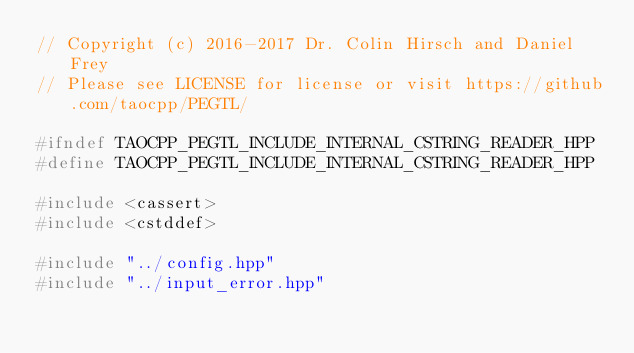<code> <loc_0><loc_0><loc_500><loc_500><_C++_>// Copyright (c) 2016-2017 Dr. Colin Hirsch and Daniel Frey
// Please see LICENSE for license or visit https://github.com/taocpp/PEGTL/

#ifndef TAOCPP_PEGTL_INCLUDE_INTERNAL_CSTRING_READER_HPP
#define TAOCPP_PEGTL_INCLUDE_INTERNAL_CSTRING_READER_HPP

#include <cassert>
#include <cstddef>

#include "../config.hpp"
#include "../input_error.hpp"
</code> 